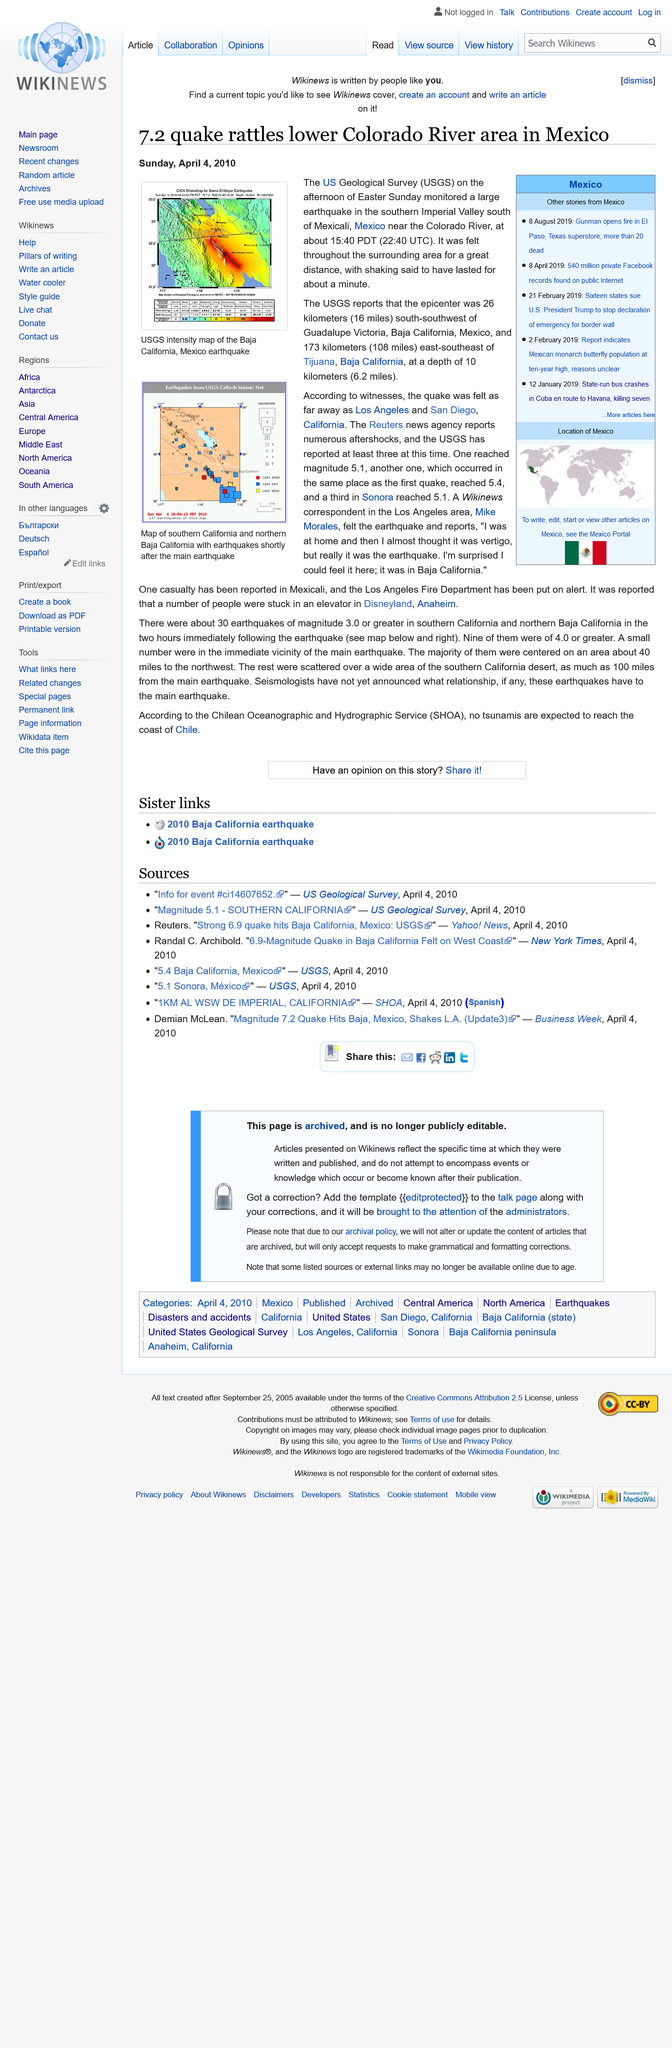Point out several critical features in this image. The earthquake was reported by the United States Geological Survey (USGS). The shaking was said to have lasted for about a minute, as stated. Aftershocks were reported by the Reuters news agency. 